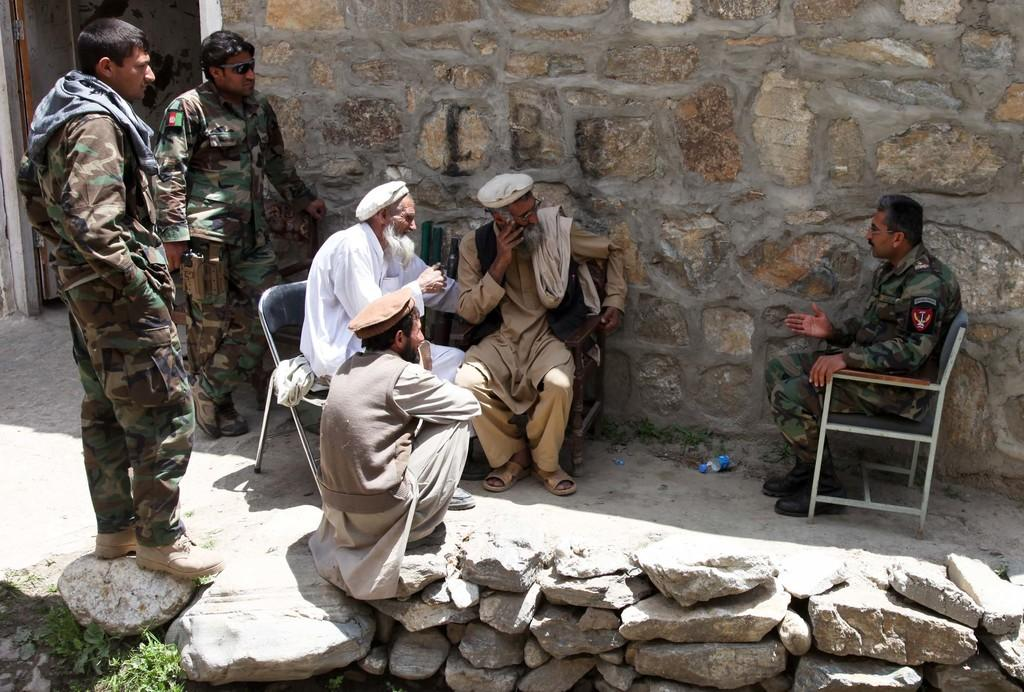What are the people in the image doing? There are people sitting and standing in the image. What can be seen in the background of the image? There is a wall and a door in the background of the image. Where is the playground located in the image? There is no playground present in the image. Can you see the dad wearing a crown in the image? There is no dad or crown present in the image. 